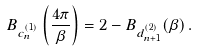Convert formula to latex. <formula><loc_0><loc_0><loc_500><loc_500>B _ { c _ { n } ^ { ( 1 ) } } \left ( \frac { 4 \pi } { \beta } \right ) = 2 - B _ { d _ { n + 1 } ^ { ( 2 ) } } ( \beta ) \, .</formula> 